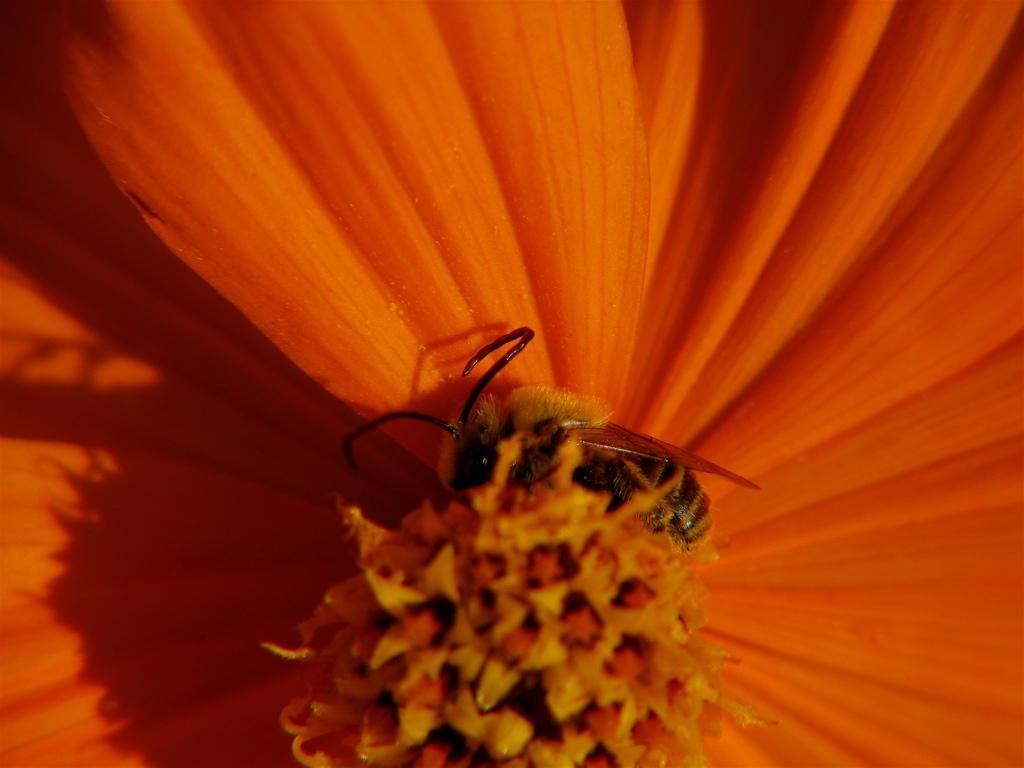Can you describe this image briefly? It is a zoomed in picture of a flower. We can also see the insect. 